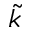Convert formula to latex. <formula><loc_0><loc_0><loc_500><loc_500>\tilde { k }</formula> 